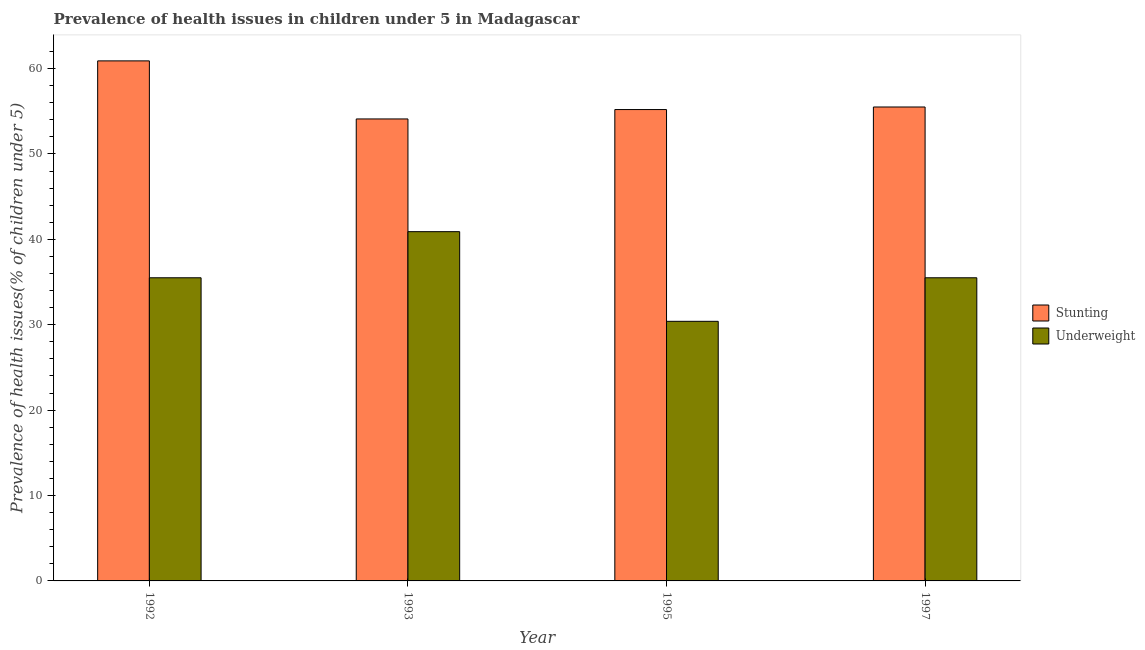How many groups of bars are there?
Offer a terse response. 4. Are the number of bars per tick equal to the number of legend labels?
Provide a short and direct response. Yes. How many bars are there on the 3rd tick from the right?
Give a very brief answer. 2. What is the percentage of underweight children in 1997?
Your response must be concise. 35.5. Across all years, what is the maximum percentage of underweight children?
Your answer should be very brief. 40.9. Across all years, what is the minimum percentage of stunted children?
Ensure brevity in your answer.  54.1. In which year was the percentage of stunted children maximum?
Provide a succinct answer. 1992. In which year was the percentage of underweight children minimum?
Keep it short and to the point. 1995. What is the total percentage of stunted children in the graph?
Offer a terse response. 225.7. What is the difference between the percentage of underweight children in 1993 and that in 1995?
Your answer should be very brief. 10.5. What is the difference between the percentage of underweight children in 1995 and the percentage of stunted children in 1993?
Give a very brief answer. -10.5. What is the average percentage of stunted children per year?
Offer a very short reply. 56.43. In how many years, is the percentage of underweight children greater than 32 %?
Offer a very short reply. 3. What is the ratio of the percentage of stunted children in 1992 to that in 1995?
Keep it short and to the point. 1.1. Is the difference between the percentage of underweight children in 1992 and 1995 greater than the difference between the percentage of stunted children in 1992 and 1995?
Ensure brevity in your answer.  No. What is the difference between the highest and the second highest percentage of stunted children?
Offer a very short reply. 5.4. What is the difference between the highest and the lowest percentage of stunted children?
Your answer should be compact. 6.8. Is the sum of the percentage of stunted children in 1992 and 1997 greater than the maximum percentage of underweight children across all years?
Your answer should be very brief. Yes. What does the 1st bar from the left in 1995 represents?
Ensure brevity in your answer.  Stunting. What does the 2nd bar from the right in 1992 represents?
Give a very brief answer. Stunting. What is the difference between two consecutive major ticks on the Y-axis?
Your answer should be compact. 10. How many legend labels are there?
Provide a succinct answer. 2. How are the legend labels stacked?
Give a very brief answer. Vertical. What is the title of the graph?
Your response must be concise. Prevalence of health issues in children under 5 in Madagascar. What is the label or title of the Y-axis?
Give a very brief answer. Prevalence of health issues(% of children under 5). What is the Prevalence of health issues(% of children under 5) of Stunting in 1992?
Provide a short and direct response. 60.9. What is the Prevalence of health issues(% of children under 5) of Underweight in 1992?
Provide a succinct answer. 35.5. What is the Prevalence of health issues(% of children under 5) in Stunting in 1993?
Your answer should be very brief. 54.1. What is the Prevalence of health issues(% of children under 5) in Underweight in 1993?
Keep it short and to the point. 40.9. What is the Prevalence of health issues(% of children under 5) of Stunting in 1995?
Make the answer very short. 55.2. What is the Prevalence of health issues(% of children under 5) in Underweight in 1995?
Ensure brevity in your answer.  30.4. What is the Prevalence of health issues(% of children under 5) of Stunting in 1997?
Provide a short and direct response. 55.5. What is the Prevalence of health issues(% of children under 5) in Underweight in 1997?
Provide a succinct answer. 35.5. Across all years, what is the maximum Prevalence of health issues(% of children under 5) in Stunting?
Your answer should be compact. 60.9. Across all years, what is the maximum Prevalence of health issues(% of children under 5) of Underweight?
Your answer should be very brief. 40.9. Across all years, what is the minimum Prevalence of health issues(% of children under 5) of Stunting?
Your response must be concise. 54.1. Across all years, what is the minimum Prevalence of health issues(% of children under 5) of Underweight?
Provide a succinct answer. 30.4. What is the total Prevalence of health issues(% of children under 5) in Stunting in the graph?
Make the answer very short. 225.7. What is the total Prevalence of health issues(% of children under 5) in Underweight in the graph?
Ensure brevity in your answer.  142.3. What is the difference between the Prevalence of health issues(% of children under 5) of Underweight in 1992 and that in 1993?
Make the answer very short. -5.4. What is the difference between the Prevalence of health issues(% of children under 5) of Stunting in 1993 and that in 1995?
Give a very brief answer. -1.1. What is the difference between the Prevalence of health issues(% of children under 5) of Underweight in 1993 and that in 1995?
Make the answer very short. 10.5. What is the difference between the Prevalence of health issues(% of children under 5) of Stunting in 1993 and that in 1997?
Give a very brief answer. -1.4. What is the difference between the Prevalence of health issues(% of children under 5) of Underweight in 1995 and that in 1997?
Make the answer very short. -5.1. What is the difference between the Prevalence of health issues(% of children under 5) of Stunting in 1992 and the Prevalence of health issues(% of children under 5) of Underweight in 1993?
Keep it short and to the point. 20. What is the difference between the Prevalence of health issues(% of children under 5) in Stunting in 1992 and the Prevalence of health issues(% of children under 5) in Underweight in 1995?
Provide a short and direct response. 30.5. What is the difference between the Prevalence of health issues(% of children under 5) in Stunting in 1992 and the Prevalence of health issues(% of children under 5) in Underweight in 1997?
Provide a short and direct response. 25.4. What is the difference between the Prevalence of health issues(% of children under 5) in Stunting in 1993 and the Prevalence of health issues(% of children under 5) in Underweight in 1995?
Your answer should be very brief. 23.7. What is the difference between the Prevalence of health issues(% of children under 5) of Stunting in 1995 and the Prevalence of health issues(% of children under 5) of Underweight in 1997?
Offer a very short reply. 19.7. What is the average Prevalence of health issues(% of children under 5) of Stunting per year?
Provide a short and direct response. 56.42. What is the average Prevalence of health issues(% of children under 5) in Underweight per year?
Your answer should be very brief. 35.58. In the year 1992, what is the difference between the Prevalence of health issues(% of children under 5) of Stunting and Prevalence of health issues(% of children under 5) of Underweight?
Your answer should be very brief. 25.4. In the year 1995, what is the difference between the Prevalence of health issues(% of children under 5) in Stunting and Prevalence of health issues(% of children under 5) in Underweight?
Keep it short and to the point. 24.8. What is the ratio of the Prevalence of health issues(% of children under 5) in Stunting in 1992 to that in 1993?
Your response must be concise. 1.13. What is the ratio of the Prevalence of health issues(% of children under 5) of Underweight in 1992 to that in 1993?
Your answer should be very brief. 0.87. What is the ratio of the Prevalence of health issues(% of children under 5) of Stunting in 1992 to that in 1995?
Your response must be concise. 1.1. What is the ratio of the Prevalence of health issues(% of children under 5) in Underweight in 1992 to that in 1995?
Your answer should be very brief. 1.17. What is the ratio of the Prevalence of health issues(% of children under 5) of Stunting in 1992 to that in 1997?
Your answer should be compact. 1.1. What is the ratio of the Prevalence of health issues(% of children under 5) of Stunting in 1993 to that in 1995?
Your answer should be very brief. 0.98. What is the ratio of the Prevalence of health issues(% of children under 5) in Underweight in 1993 to that in 1995?
Make the answer very short. 1.35. What is the ratio of the Prevalence of health issues(% of children under 5) in Stunting in 1993 to that in 1997?
Provide a short and direct response. 0.97. What is the ratio of the Prevalence of health issues(% of children under 5) of Underweight in 1993 to that in 1997?
Keep it short and to the point. 1.15. What is the ratio of the Prevalence of health issues(% of children under 5) in Stunting in 1995 to that in 1997?
Offer a terse response. 0.99. What is the ratio of the Prevalence of health issues(% of children under 5) of Underweight in 1995 to that in 1997?
Your answer should be compact. 0.86. What is the difference between the highest and the second highest Prevalence of health issues(% of children under 5) of Stunting?
Keep it short and to the point. 5.4. What is the difference between the highest and the lowest Prevalence of health issues(% of children under 5) in Stunting?
Offer a very short reply. 6.8. 